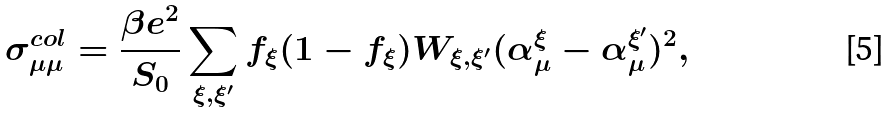Convert formula to latex. <formula><loc_0><loc_0><loc_500><loc_500>\sigma _ { \mu \mu } ^ { c o l } = \frac { \beta e ^ { 2 } } { S _ { 0 } } \sum _ { \xi , \xi ^ { \prime } } f _ { \xi } ( 1 - f _ { \xi } ) W _ { \xi , \xi ^ { \prime } } ( \alpha _ { \mu } ^ { \xi } - \alpha _ { \mu } ^ { \xi ^ { \prime } } ) ^ { 2 } ,</formula> 